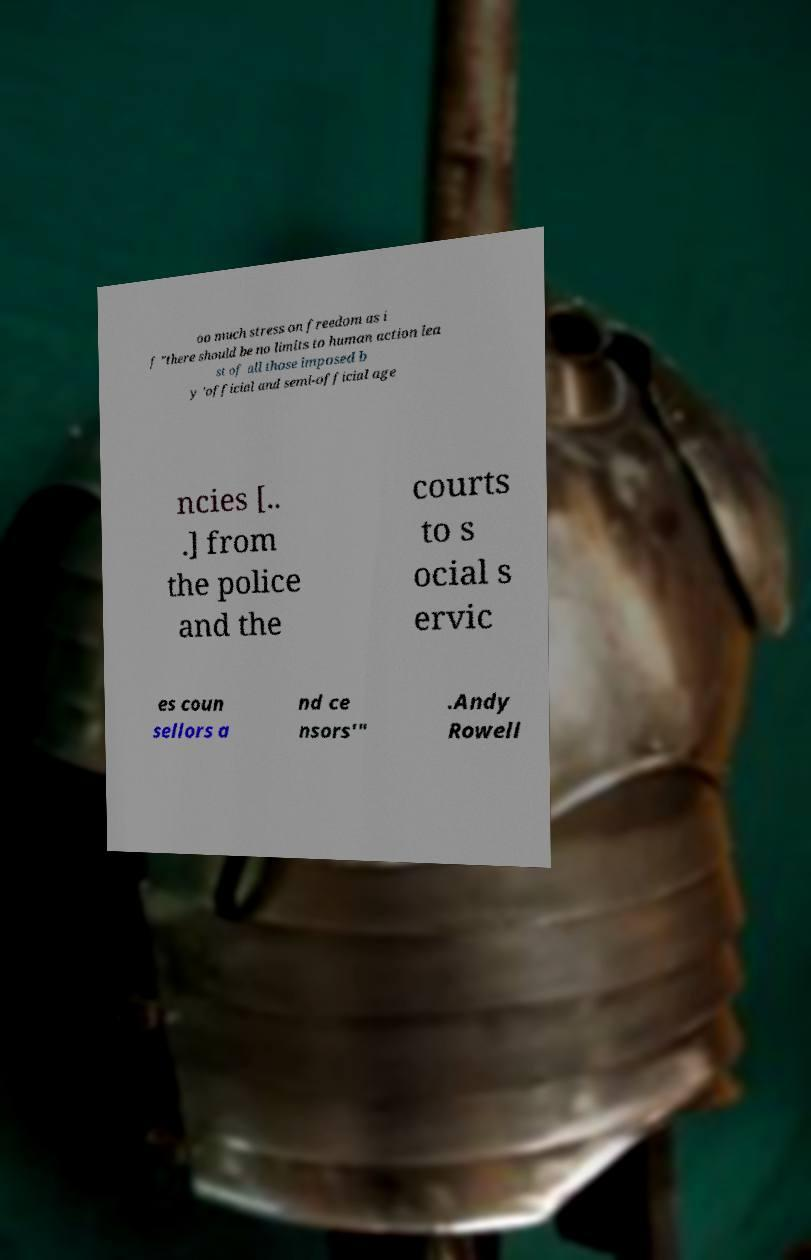There's text embedded in this image that I need extracted. Can you transcribe it verbatim? oo much stress on freedom as i f "there should be no limits to human action lea st of all those imposed b y 'official and semi-official age ncies [.. .] from the police and the courts to s ocial s ervic es coun sellors a nd ce nsors'" .Andy Rowell 